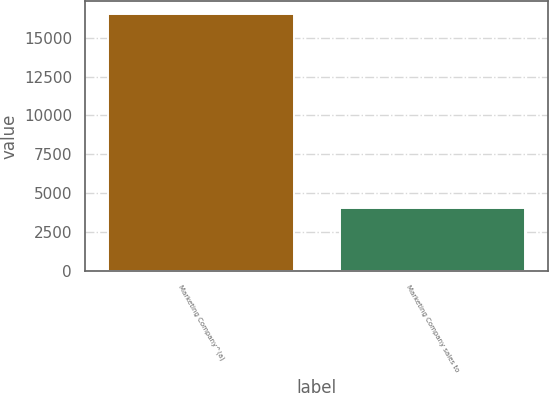Convert chart. <chart><loc_0><loc_0><loc_500><loc_500><bar_chart><fcel>Marketing Company^(a)<fcel>Marketing Company sales to<nl><fcel>16551<fcel>4037.4<nl></chart> 